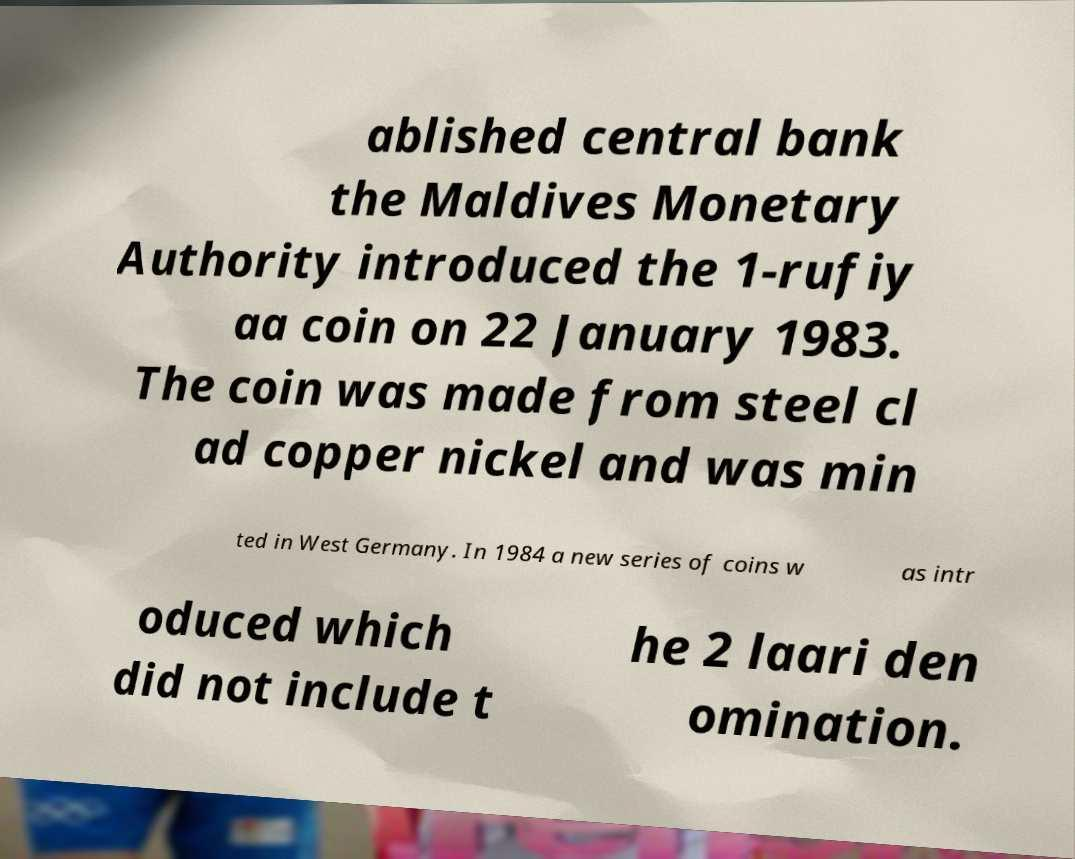Please identify and transcribe the text found in this image. ablished central bank the Maldives Monetary Authority introduced the 1-rufiy aa coin on 22 January 1983. The coin was made from steel cl ad copper nickel and was min ted in West Germany. In 1984 a new series of coins w as intr oduced which did not include t he 2 laari den omination. 